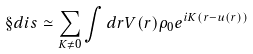Convert formula to latex. <formula><loc_0><loc_0><loc_500><loc_500>\S d i s \simeq \sum _ { K \ne 0 } \int d r V ( r ) \rho _ { 0 } e ^ { i K ( r - u ( r ) ) }</formula> 